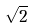<formula> <loc_0><loc_0><loc_500><loc_500>\sqrt { 2 }</formula> 